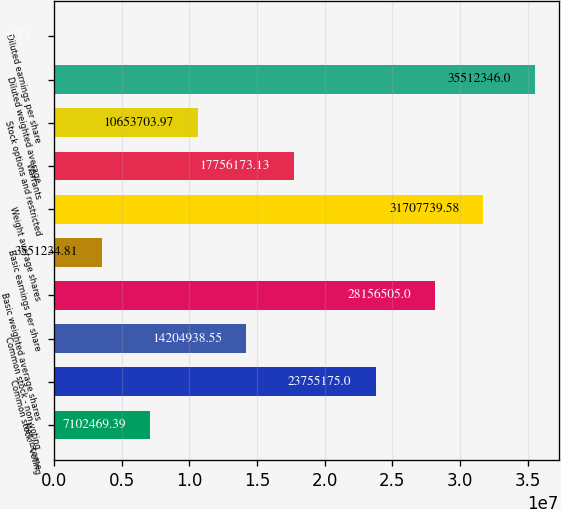<chart> <loc_0><loc_0><loc_500><loc_500><bar_chart><fcel>Net income<fcel>Common stock - voting<fcel>Common stock - non-voting<fcel>Basic weighted average shares<fcel>Basic earnings per share<fcel>Weight average shares<fcel>Warrants<fcel>Stock options and restricted<fcel>Diluted weighted average<fcel>Diluted earnings per share<nl><fcel>7.10247e+06<fcel>2.37552e+07<fcel>1.42049e+07<fcel>2.81565e+07<fcel>3.55123e+06<fcel>3.17077e+07<fcel>1.77562e+07<fcel>1.06537e+07<fcel>3.55123e+07<fcel>0.23<nl></chart> 